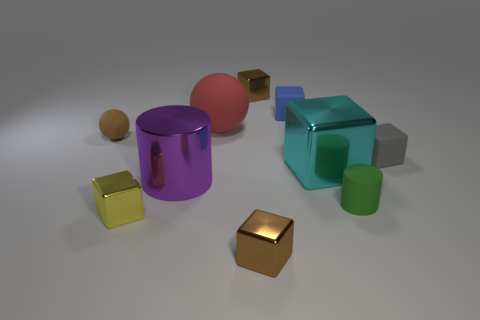There is a brown metal thing in front of the yellow metal cube; what is its shape? The shape in front of the yellow metal cube appears to be a rectangular prism with a more complex geometry than a simple cube, owing to the visible shadows and edges that suggest a depth dimension. 